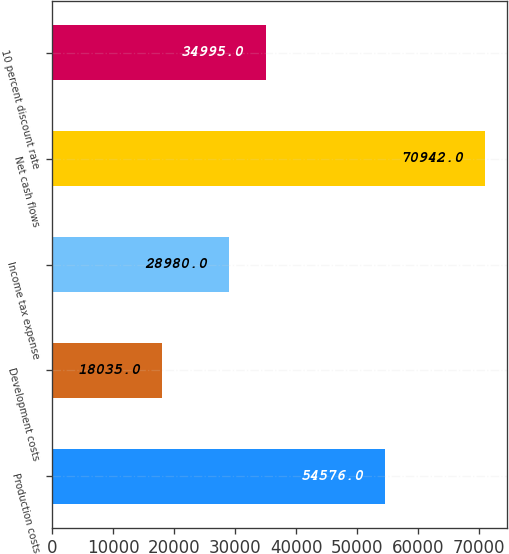<chart> <loc_0><loc_0><loc_500><loc_500><bar_chart><fcel>Production costs<fcel>Development costs<fcel>Income tax expense<fcel>Net cash flows<fcel>10 percent discount rate<nl><fcel>54576<fcel>18035<fcel>28980<fcel>70942<fcel>34995<nl></chart> 